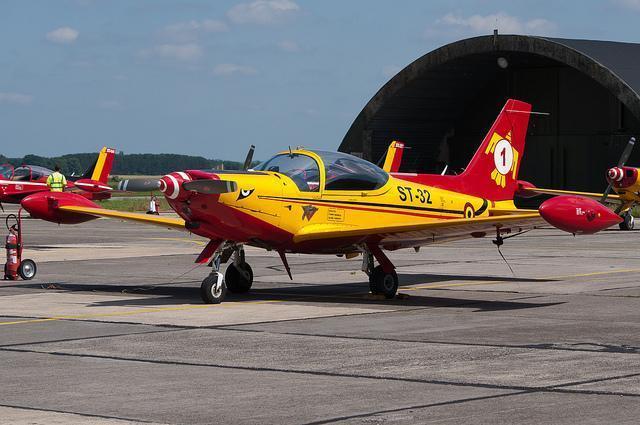How many airplanes are in the picture?
Give a very brief answer. 3. 